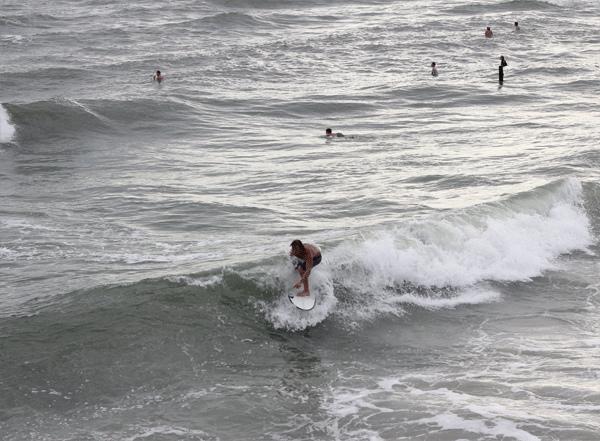How many people in the water?
Give a very brief answer. 7. How many suitcases have a colorful floral design?
Give a very brief answer. 0. 